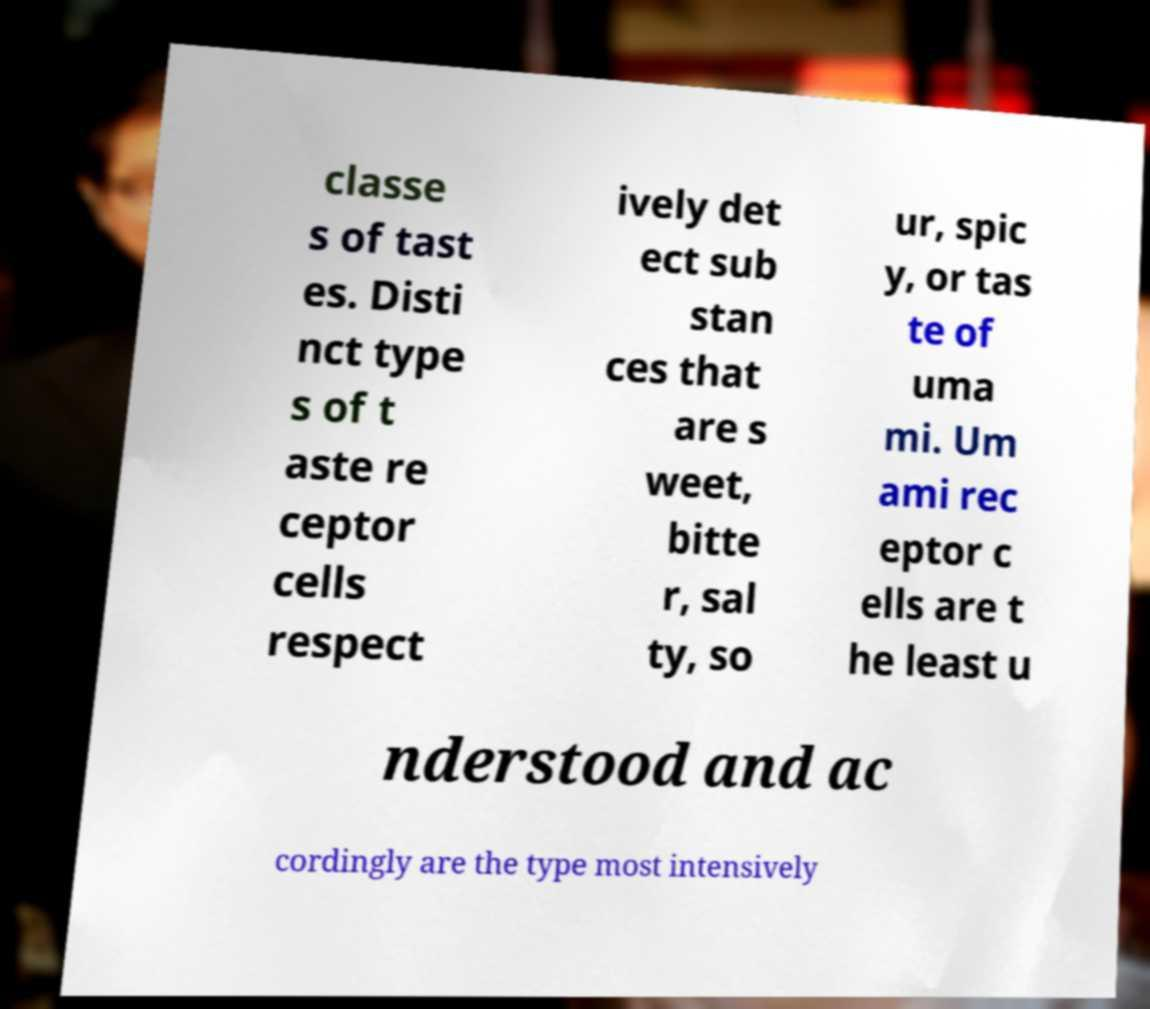Please read and relay the text visible in this image. What does it say? classe s of tast es. Disti nct type s of t aste re ceptor cells respect ively det ect sub stan ces that are s weet, bitte r, sal ty, so ur, spic y, or tas te of uma mi. Um ami rec eptor c ells are t he least u nderstood and ac cordingly are the type most intensively 